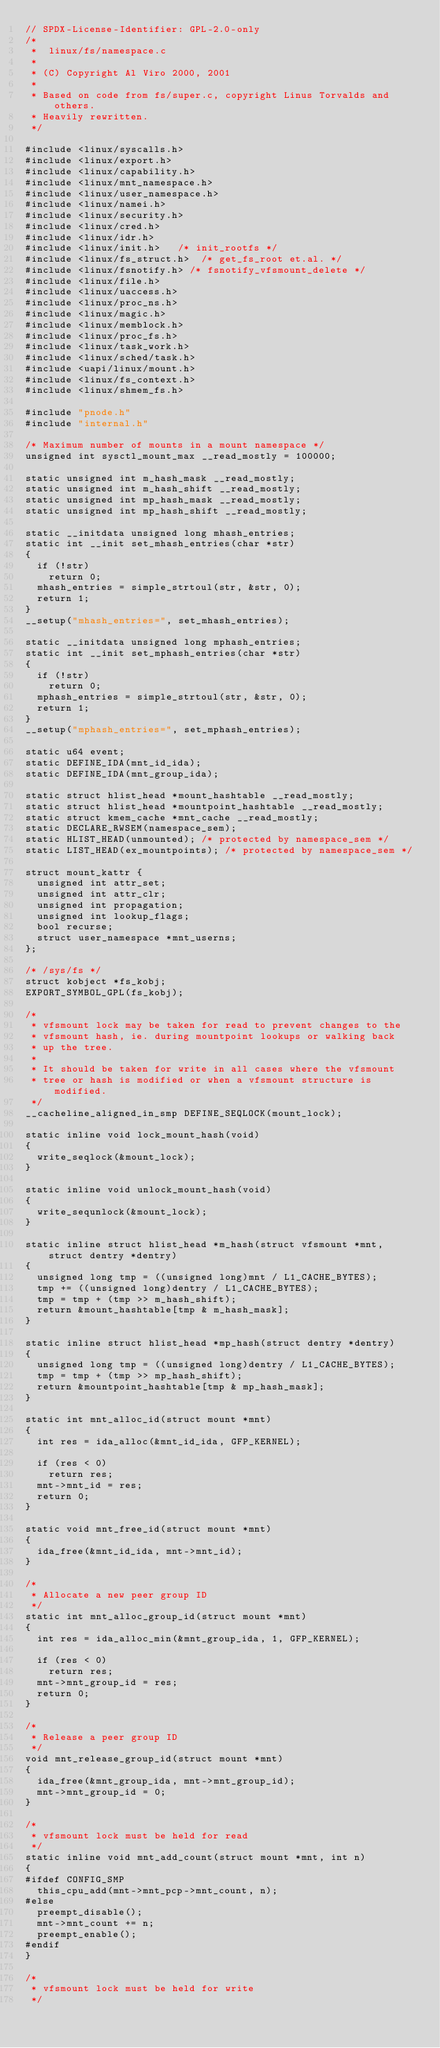<code> <loc_0><loc_0><loc_500><loc_500><_C_>// SPDX-License-Identifier: GPL-2.0-only
/*
 *  linux/fs/namespace.c
 *
 * (C) Copyright Al Viro 2000, 2001
 *
 * Based on code from fs/super.c, copyright Linus Torvalds and others.
 * Heavily rewritten.
 */

#include <linux/syscalls.h>
#include <linux/export.h>
#include <linux/capability.h>
#include <linux/mnt_namespace.h>
#include <linux/user_namespace.h>
#include <linux/namei.h>
#include <linux/security.h>
#include <linux/cred.h>
#include <linux/idr.h>
#include <linux/init.h>		/* init_rootfs */
#include <linux/fs_struct.h>	/* get_fs_root et.al. */
#include <linux/fsnotify.h>	/* fsnotify_vfsmount_delete */
#include <linux/file.h>
#include <linux/uaccess.h>
#include <linux/proc_ns.h>
#include <linux/magic.h>
#include <linux/memblock.h>
#include <linux/proc_fs.h>
#include <linux/task_work.h>
#include <linux/sched/task.h>
#include <uapi/linux/mount.h>
#include <linux/fs_context.h>
#include <linux/shmem_fs.h>

#include "pnode.h"
#include "internal.h"

/* Maximum number of mounts in a mount namespace */
unsigned int sysctl_mount_max __read_mostly = 100000;

static unsigned int m_hash_mask __read_mostly;
static unsigned int m_hash_shift __read_mostly;
static unsigned int mp_hash_mask __read_mostly;
static unsigned int mp_hash_shift __read_mostly;

static __initdata unsigned long mhash_entries;
static int __init set_mhash_entries(char *str)
{
	if (!str)
		return 0;
	mhash_entries = simple_strtoul(str, &str, 0);
	return 1;
}
__setup("mhash_entries=", set_mhash_entries);

static __initdata unsigned long mphash_entries;
static int __init set_mphash_entries(char *str)
{
	if (!str)
		return 0;
	mphash_entries = simple_strtoul(str, &str, 0);
	return 1;
}
__setup("mphash_entries=", set_mphash_entries);

static u64 event;
static DEFINE_IDA(mnt_id_ida);
static DEFINE_IDA(mnt_group_ida);

static struct hlist_head *mount_hashtable __read_mostly;
static struct hlist_head *mountpoint_hashtable __read_mostly;
static struct kmem_cache *mnt_cache __read_mostly;
static DECLARE_RWSEM(namespace_sem);
static HLIST_HEAD(unmounted);	/* protected by namespace_sem */
static LIST_HEAD(ex_mountpoints); /* protected by namespace_sem */

struct mount_kattr {
	unsigned int attr_set;
	unsigned int attr_clr;
	unsigned int propagation;
	unsigned int lookup_flags;
	bool recurse;
	struct user_namespace *mnt_userns;
};

/* /sys/fs */
struct kobject *fs_kobj;
EXPORT_SYMBOL_GPL(fs_kobj);

/*
 * vfsmount lock may be taken for read to prevent changes to the
 * vfsmount hash, ie. during mountpoint lookups or walking back
 * up the tree.
 *
 * It should be taken for write in all cases where the vfsmount
 * tree or hash is modified or when a vfsmount structure is modified.
 */
__cacheline_aligned_in_smp DEFINE_SEQLOCK(mount_lock);

static inline void lock_mount_hash(void)
{
	write_seqlock(&mount_lock);
}

static inline void unlock_mount_hash(void)
{
	write_sequnlock(&mount_lock);
}

static inline struct hlist_head *m_hash(struct vfsmount *mnt, struct dentry *dentry)
{
	unsigned long tmp = ((unsigned long)mnt / L1_CACHE_BYTES);
	tmp += ((unsigned long)dentry / L1_CACHE_BYTES);
	tmp = tmp + (tmp >> m_hash_shift);
	return &mount_hashtable[tmp & m_hash_mask];
}

static inline struct hlist_head *mp_hash(struct dentry *dentry)
{
	unsigned long tmp = ((unsigned long)dentry / L1_CACHE_BYTES);
	tmp = tmp + (tmp >> mp_hash_shift);
	return &mountpoint_hashtable[tmp & mp_hash_mask];
}

static int mnt_alloc_id(struct mount *mnt)
{
	int res = ida_alloc(&mnt_id_ida, GFP_KERNEL);

	if (res < 0)
		return res;
	mnt->mnt_id = res;
	return 0;
}

static void mnt_free_id(struct mount *mnt)
{
	ida_free(&mnt_id_ida, mnt->mnt_id);
}

/*
 * Allocate a new peer group ID
 */
static int mnt_alloc_group_id(struct mount *mnt)
{
	int res = ida_alloc_min(&mnt_group_ida, 1, GFP_KERNEL);

	if (res < 0)
		return res;
	mnt->mnt_group_id = res;
	return 0;
}

/*
 * Release a peer group ID
 */
void mnt_release_group_id(struct mount *mnt)
{
	ida_free(&mnt_group_ida, mnt->mnt_group_id);
	mnt->mnt_group_id = 0;
}

/*
 * vfsmount lock must be held for read
 */
static inline void mnt_add_count(struct mount *mnt, int n)
{
#ifdef CONFIG_SMP
	this_cpu_add(mnt->mnt_pcp->mnt_count, n);
#else
	preempt_disable();
	mnt->mnt_count += n;
	preempt_enable();
#endif
}

/*
 * vfsmount lock must be held for write
 */</code> 